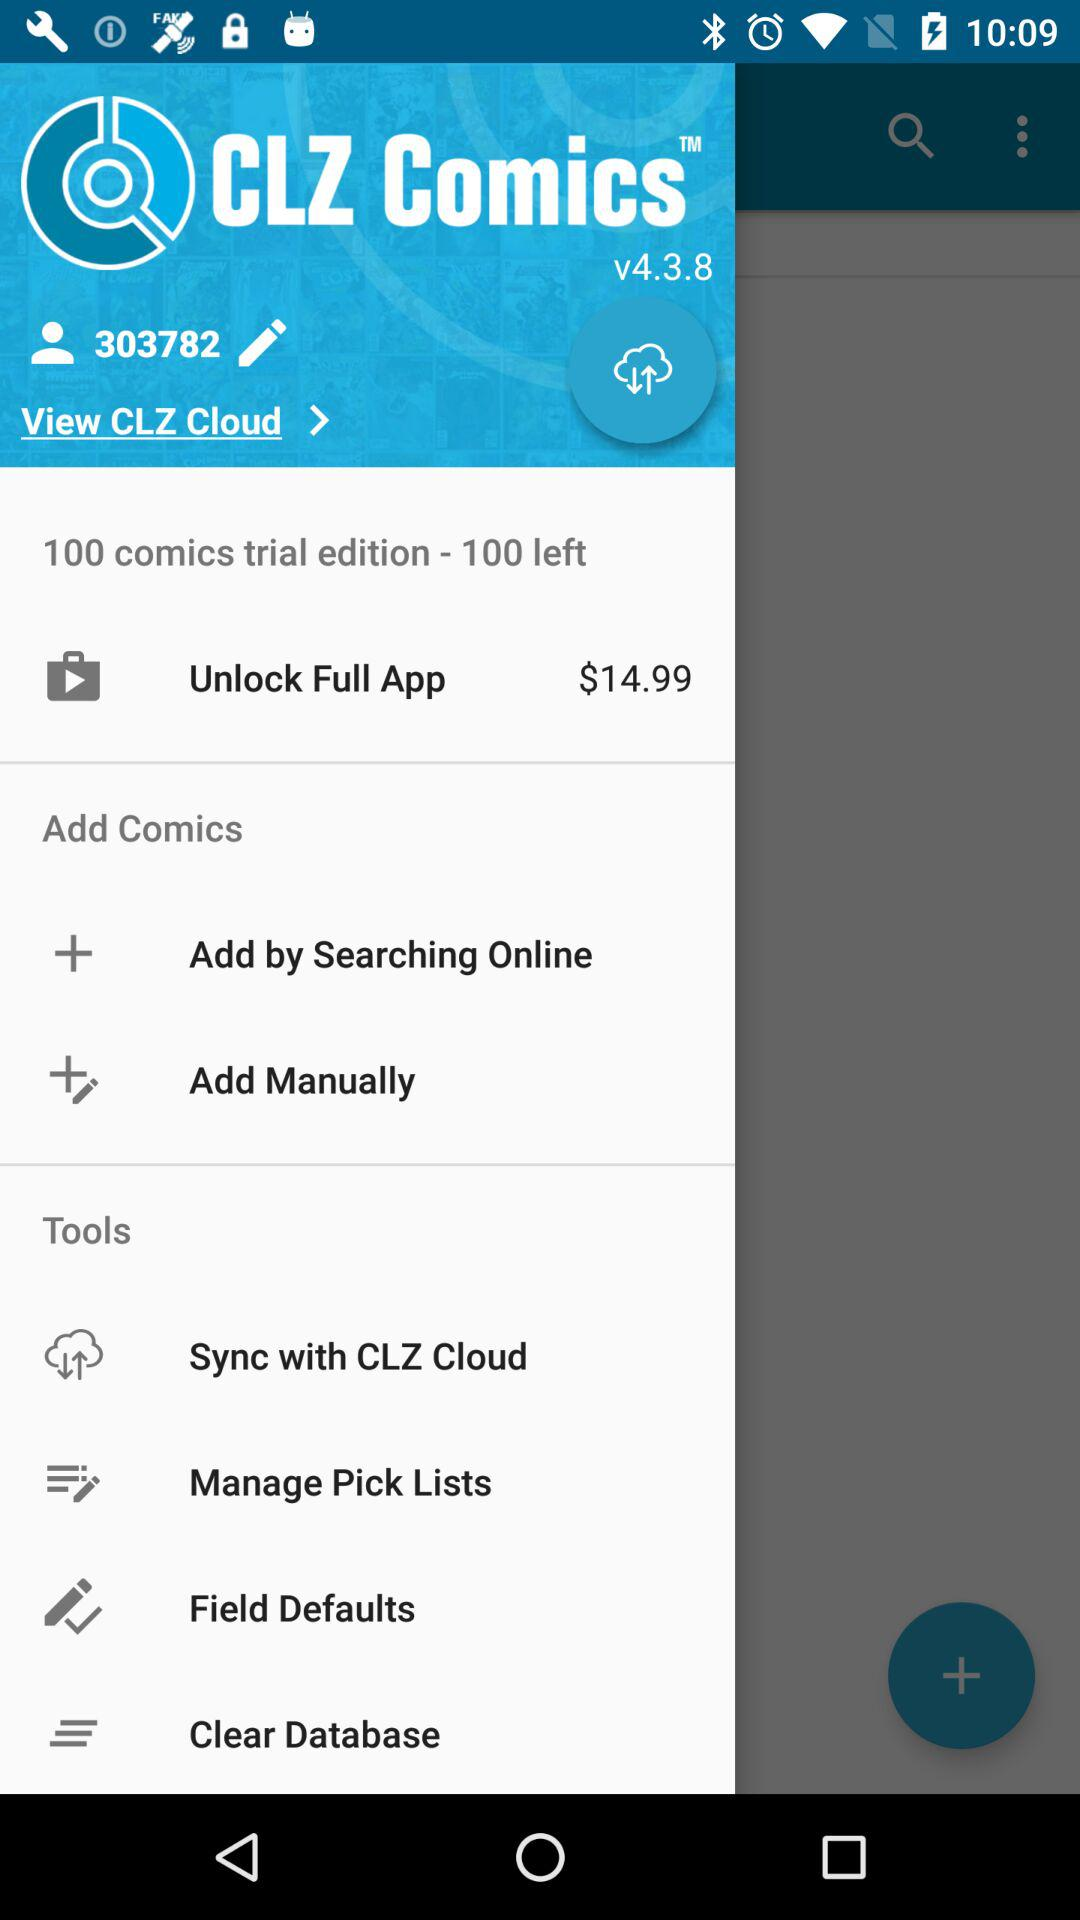How much of the amount is required to unlock the full app? The amount required to unlock the full app is $14.99. 